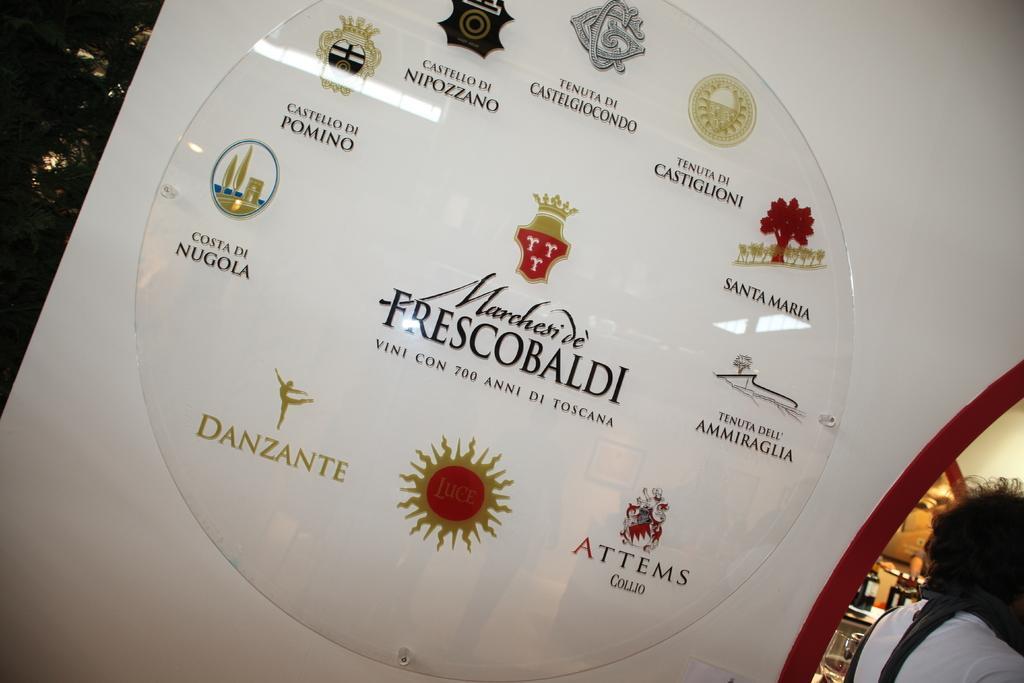Can you describe this image briefly? This image is taken outdoors. In this image there is a wall and there is a board with a few images and there is a text on it. On the right side of the image there are a few objects and there is a person. 